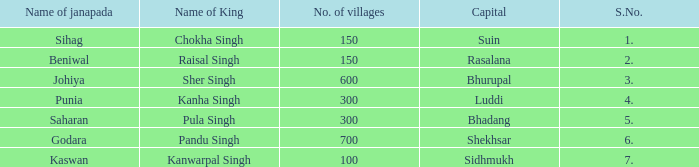What is the highest S number with a capital of Shekhsar? 6.0. 